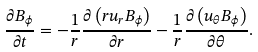Convert formula to latex. <formula><loc_0><loc_0><loc_500><loc_500>\frac { \partial B _ { \phi } } { \partial t } = - \frac { 1 } { r } \frac { \partial \left ( r u _ { r } B _ { \phi } \right ) } { \partial r } - \frac { 1 } { r } \frac { \partial \left ( u _ { \theta } B _ { \phi } \right ) } { \partial \theta } .</formula> 